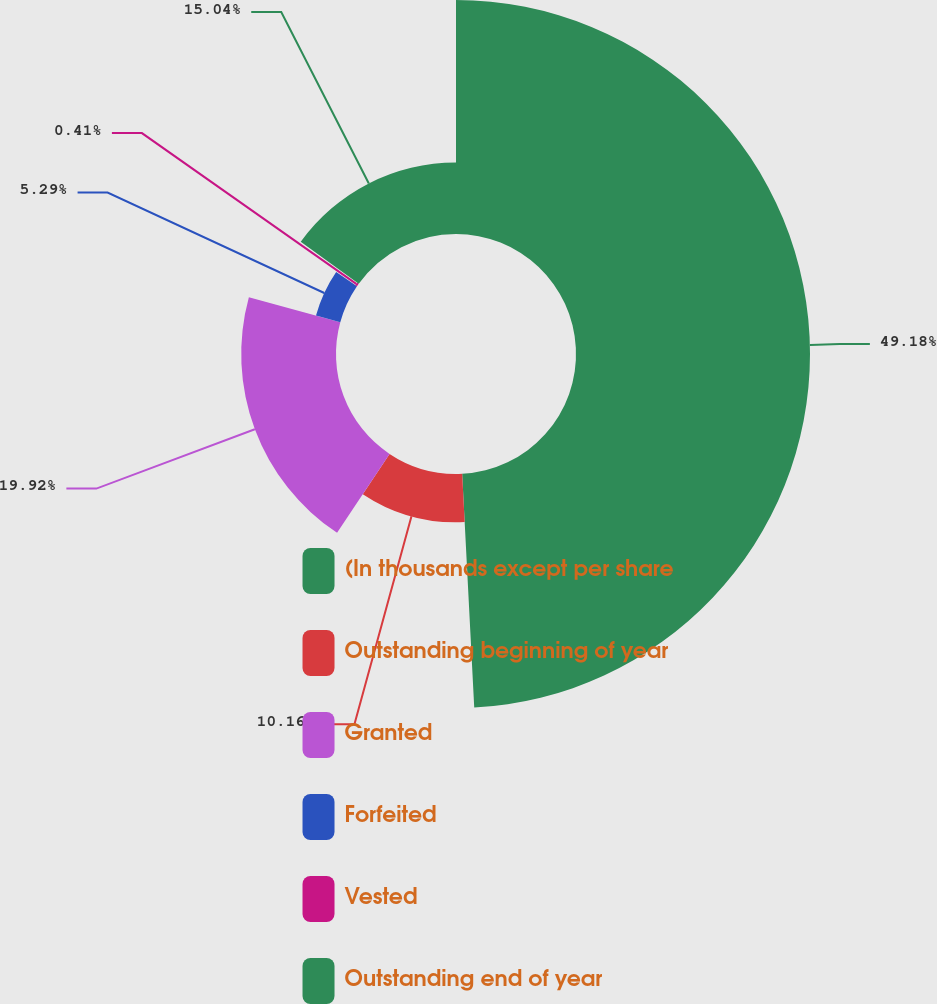<chart> <loc_0><loc_0><loc_500><loc_500><pie_chart><fcel>(In thousands except per share<fcel>Outstanding beginning of year<fcel>Granted<fcel>Forfeited<fcel>Vested<fcel>Outstanding end of year<nl><fcel>49.18%<fcel>10.16%<fcel>19.92%<fcel>5.29%<fcel>0.41%<fcel>15.04%<nl></chart> 